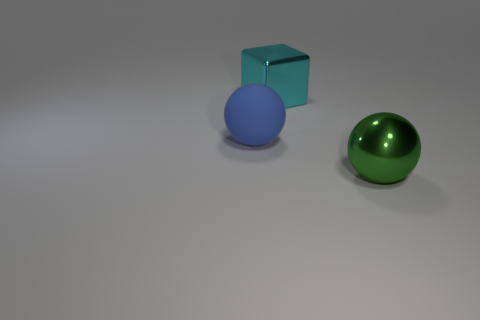What number of objects are big balls behind the green metal object or blue rubber things that are on the left side of the metallic block? In the image, there is one large green metallic ball, which does not meet the criteria of being behind the green metal object as it is in the foreground. Additionally, there are no blue rubber objects on the left side of the metallic block. Hence, the total number of objects fitting the specific conditions of your question is zero. 